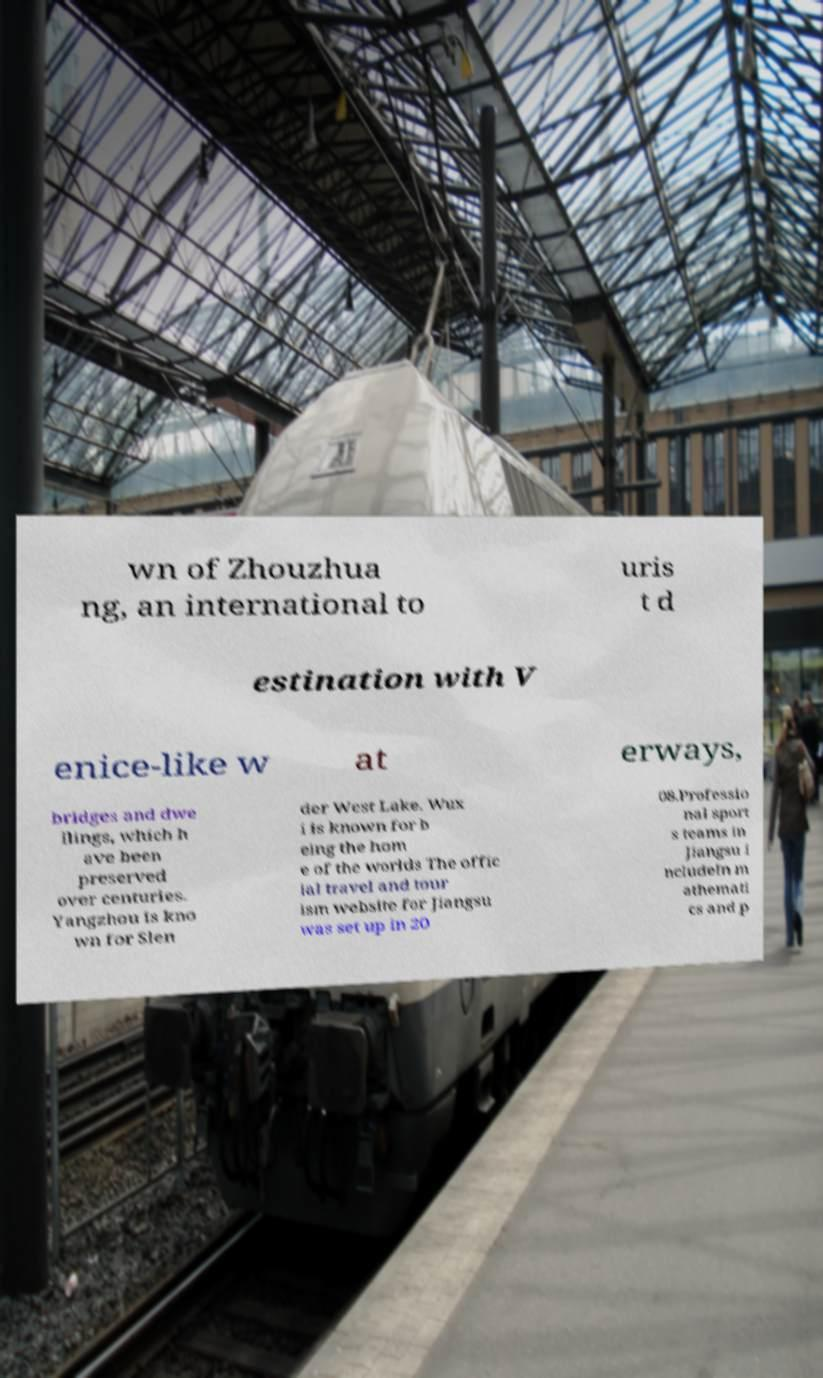Please identify and transcribe the text found in this image. wn of Zhouzhua ng, an international to uris t d estination with V enice-like w at erways, bridges and dwe llings, which h ave been preserved over centuries. Yangzhou is kno wn for Slen der West Lake. Wux i is known for b eing the hom e of the worlds The offic ial travel and tour ism website for Jiangsu was set up in 20 08.Professio nal sport s teams in Jiangsu i ncludeIn m athemati cs and p 